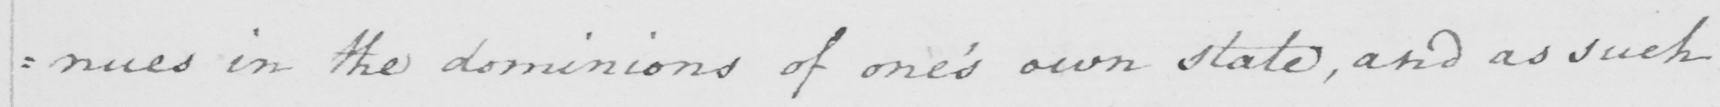What is written in this line of handwriting? : nues in the dominions of one ' s own state , and as such 